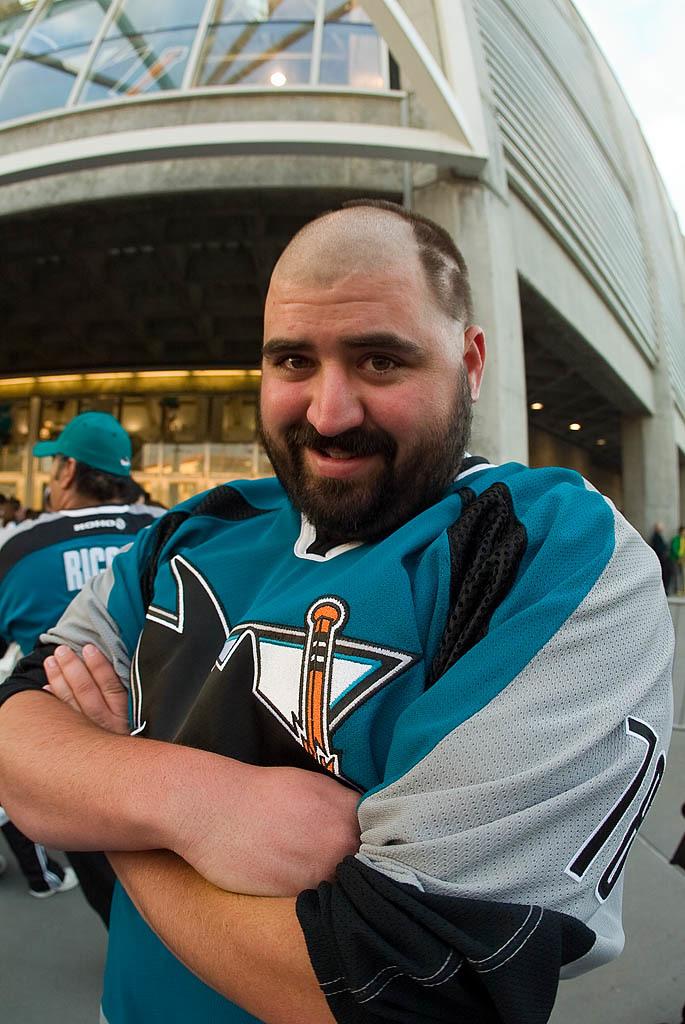What number is on the man's jersey?
Your answer should be compact. 78. What is the last name of the jersey in the back ground?
Offer a terse response. Unanswerable. 